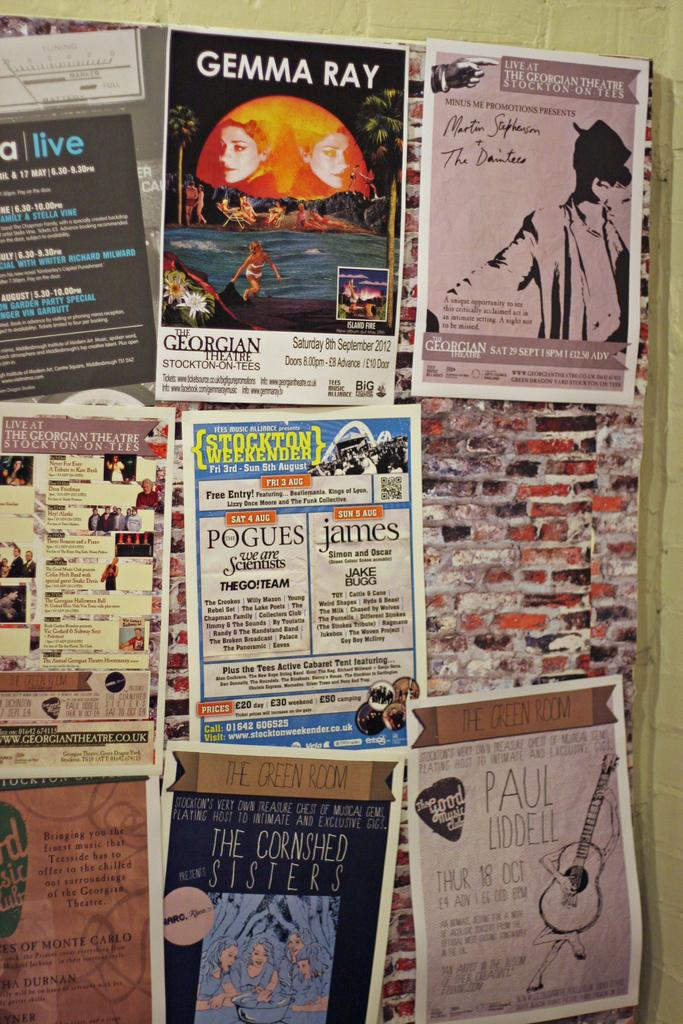<image>
Present a compact description of the photo's key features. A poster board is covered in flyers such as one for a Paul Liddell concert. 